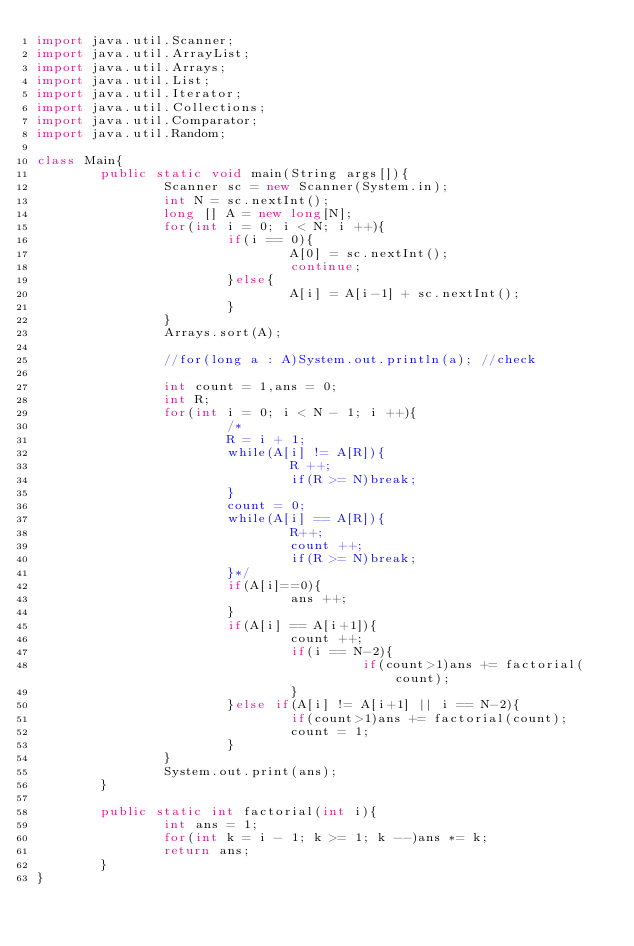Convert code to text. <code><loc_0><loc_0><loc_500><loc_500><_Java_>import java.util.Scanner;
import java.util.ArrayList;
import java.util.Arrays;
import java.util.List;
import java.util.Iterator;
import java.util.Collections;
import java.util.Comparator;
import java.util.Random;

class Main{
        public static void main(String args[]){
                Scanner sc = new Scanner(System.in);
                int N = sc.nextInt();
                long [] A = new long[N];
                for(int i = 0; i < N; i ++){
                        if(i == 0){
                                A[0] = sc.nextInt();
                                continue;
                        }else{
                                A[i] = A[i-1] + sc.nextInt();
                        }
                }
                Arrays.sort(A);

                //for(long a : A)System.out.println(a); //check

                int count = 1,ans = 0;
                int R;
                for(int i = 0; i < N - 1; i ++){
                        /*
                        R = i + 1;
                        while(A[i] != A[R]){
                                R ++;
                                if(R >= N)break;
                        }
                        count = 0;
                        while(A[i] == A[R]){
                                R++;
                                count ++;
                                if(R >= N)break;
                        }*/
                        if(A[i]==0){
                                ans ++;
                        }
                        if(A[i] == A[i+1]){
                                count ++;
                                if(i == N-2){
                                         if(count>1)ans += factorial(count);
                                }
                        }else if(A[i] != A[i+1] || i == N-2){
                                if(count>1)ans += factorial(count);
                                count = 1;
                        }
                }
                System.out.print(ans);
        }

        public static int factorial(int i){
                int ans = 1;
                for(int k = i - 1; k >= 1; k --)ans *= k;
                return ans;
        }
}
</code> 